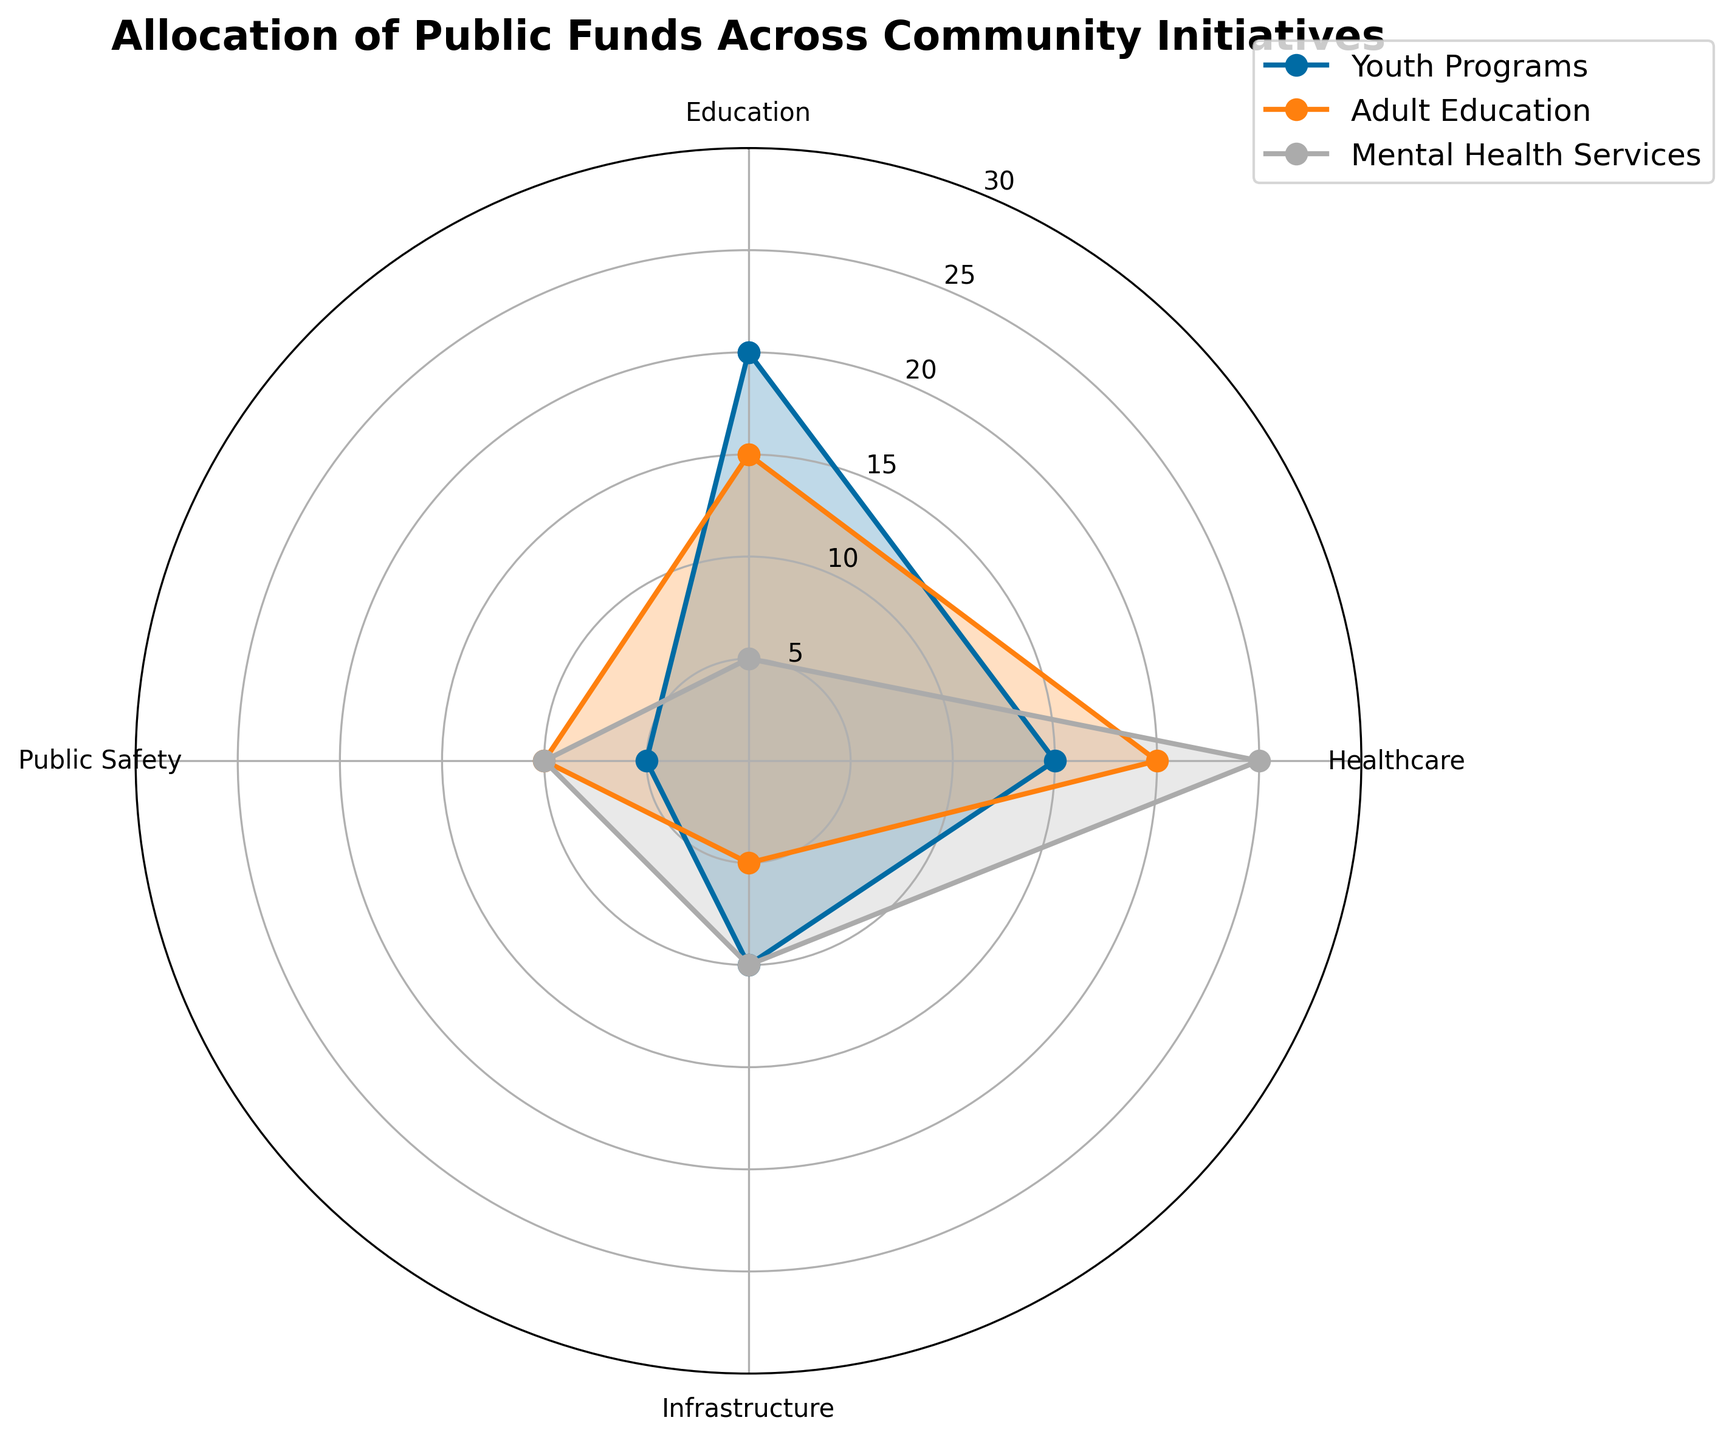What's the overall title of the radar chart? The overall title of the radar chart is displayed at the top of the plot. It provides an immediate understanding of what the chart is about. The title reads "Allocation of Public Funds Across Community Initiatives".
Answer: Allocation of Public Funds Across Community Initiatives Which community initiative shows the highest allocation to Healthcare? To answer this, look at the Healthcare axis and see which initiative has the most extended line segment towards it. Mental Health Services has the highest allocation to Healthcare.
Answer: Mental Health Services What is the difference in fund allocation to Education between Youth Programs and Adult Education? Locate the points representing fund allocation to Education on the radar chart for Youth Programs and Adult Education. Youth Programs has 20, and Adult Education has 15 allocated to Education. The difference is 20 - 15 = 5.
Answer: 5 Among the initiatives shown, which one has the lowest allocation to Infrastructure? Check the Infrastructure axis for each of the initiatives. Youth Programs and Adult Education both have lower values than Mental Health Services, with Adult Education having the lowest at 5.
Answer: Adult Education What is the sum of the allocations to Public Safety for all three initiatives? Identify the allocations for Public Safety from the radar chart: Youth Programs (5), Adult Education (10), and Mental Health Services (10). Sum these values: 5 + 10 + 10 = 25.
Answer: 25 Which community initiative has the most balanced allocation across all four categories? The most balanced allocation can be identified by looking for the initiative whose line segments are most evenly distributed around the center of the radar chart. Adult Education appears to have the most balanced allocation across categories.
Answer: Adult Education What is the total allocation for Healthcare and Public Safety combined for Mental Health Services? From the radar chart, find the values of Mental Health Services for Healthcare (25) and Public Safety (10). Sum these values: 25 + 10 = 35.
Answer: 35 Which initiative has the highest allocation towards Education? Identify the allocations for Education from the radar chart. Youth Programs has the highest allocation towards Education at 20.
Answer: Youth Programs How many categories are shown in the radar chart? The radar chart has categories distributed evenly around its axes. Count the number of unique axes/categories shown: Education, Healthcare, Infrastructure, and Public Safety, which makes 4 categories.
Answer: 4 